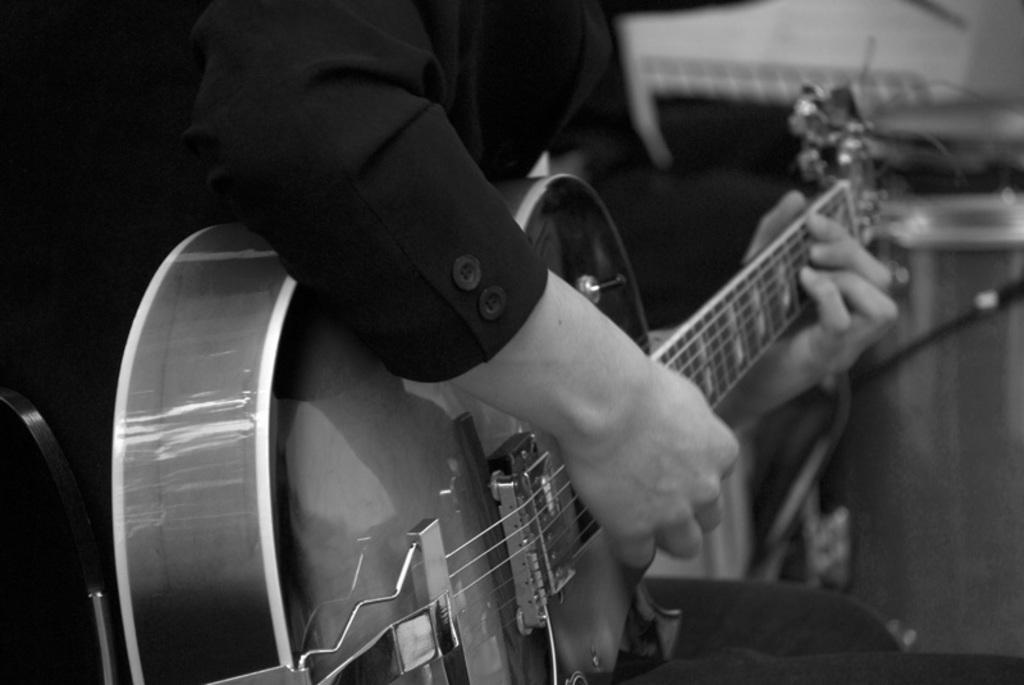Who is the main subject in the image? There is a man in the image. What is the man wearing? The man is wearing a black blazer. What object is the man holding? The man is holding a guitar. What is the man doing with the guitar? The man is playing the guitar. What type of vase is on the wall behind the man in the image? There is no vase present in the image. 